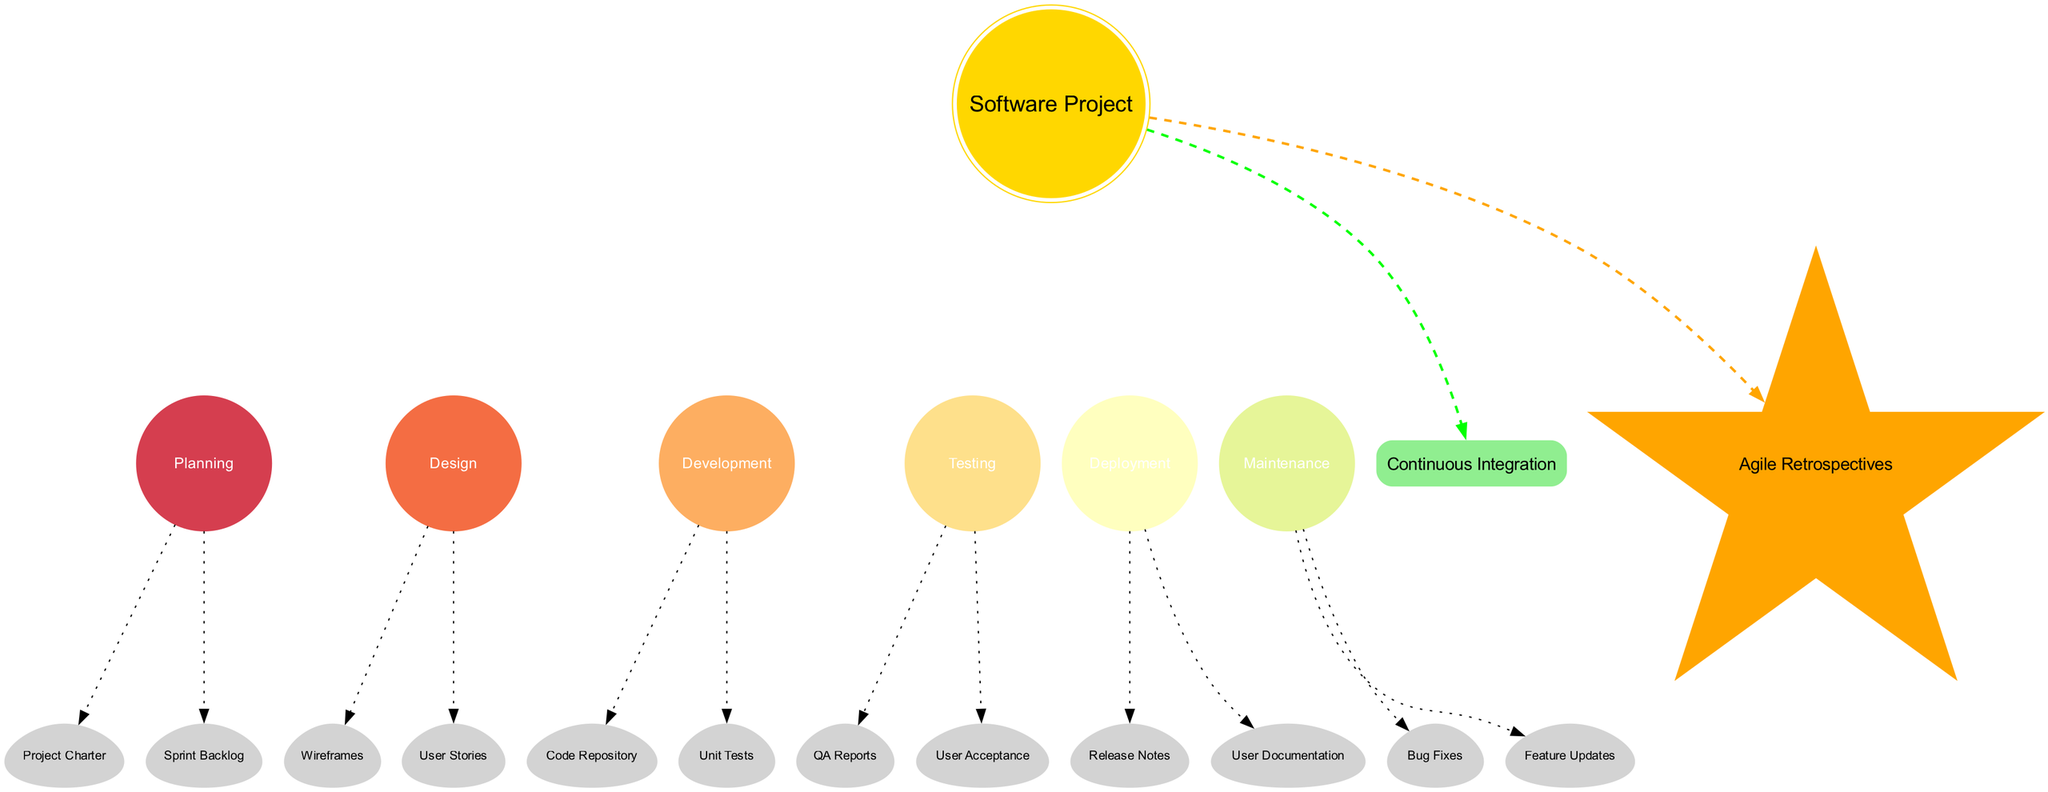What is the central body of the diagram? The central body is labeled as "Software Project." This is identified as the key feature at the center of the diagram, indicated by its distinct shape and color, making it clear that it represents the overall project.
Answer: Software Project How many planets are in the orbital diagram? There are six planets named in the diagram: Planning, Design, Development, Testing, Deployment, and Maintenance. Each planet corresponds to a phase in the software development lifecycle. Counting these, we find a total of six.
Answer: 6 What deliverable is associated with the Development planet? The Development planet has two associated deliverables: "Code Repository" and "Unit Tests." This is found by looking at the moons connected to the Development planet, which represent key deliverables of that phase.
Answer: Code Repository, Unit Tests Which phase comes before Deployment? The phase that comes directly before Deployment is Testing. This can be determined by examining the order of the planets from Planning through to Maintenance, showing their sequential relationship.
Answer: Testing What is the shape of the deliverables (moons) in the diagram? The moons representing the deliverables are shaped like eggs. This is an intrinsic property of the nodes representing deliverables, distinctly shown in the diagram.
Answer: Egg How many deliverables are associated with the Design planet? The Design planet has two deliverables associated with it: "Wireframes" and "User Stories." By looking at the moons linked to the Design planet, we find these two key deliverables.
Answer: 2 What type of node represents the asteroid belt? The asteroid belt is represented by a box shape. This distinctive shape indicates a different type of node compared to the planetary nodes and is noted for its rounded and filled style in the diagram.
Answer: Box What is the comet representing in the diagram? The comet represents "Agile Retrospectives." This is identified by its distinct star shape and orange color, which sets it apart from the other elements in the diagram, indicating its unique role.
Answer: Agile Retrospectives Which planet has the deliverable "User Acceptance"? The planet that has the deliverable "User Acceptance" is the Testing planet. This is clear upon reviewing the moons connected to the Testing planet node, where "User Acceptance" is one of the associated deliverables.
Answer: Testing 